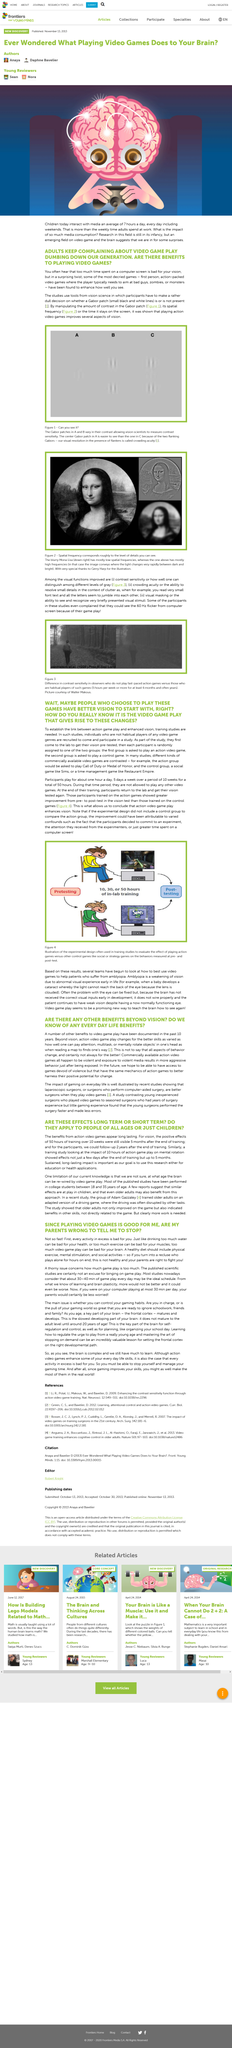Specify some key components in this picture. It is recommended that the video game component of the intervention should ideally last for 30-40 minutes daily, providing 30-40 minutes of game play. The benefits from action video games are apparent in their long-lasting impact. The past 10 years have documented numerous benefits to video game play. The purpose of this article is to investigate the potential for video games to provide sustained and long-lasting benefits through education or health-related applications. Yes, multitasking is one of the benefits of action video game play. 